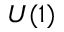Convert formula to latex. <formula><loc_0><loc_0><loc_500><loc_500>U ( 1 )</formula> 